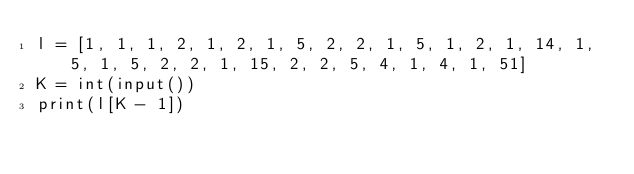<code> <loc_0><loc_0><loc_500><loc_500><_Python_>l = [1, 1, 1, 2, 1, 2, 1, 5, 2, 2, 1, 5, 1, 2, 1, 14, 1, 5, 1, 5, 2, 2, 1, 15, 2, 2, 5, 4, 1, 4, 1, 51]
K = int(input())
print(l[K - 1])</code> 